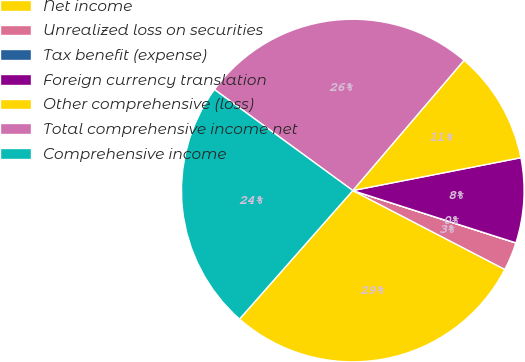Convert chart. <chart><loc_0><loc_0><loc_500><loc_500><pie_chart><fcel>Net income<fcel>Unrealized loss on securities<fcel>Tax benefit (expense)<fcel>Foreign currency translation<fcel>Other comprehensive (loss)<fcel>Total comprehensive income net<fcel>Comprehensive income<nl><fcel>28.88%<fcel>2.67%<fcel>0.01%<fcel>8.01%<fcel>10.68%<fcel>26.21%<fcel>23.54%<nl></chart> 